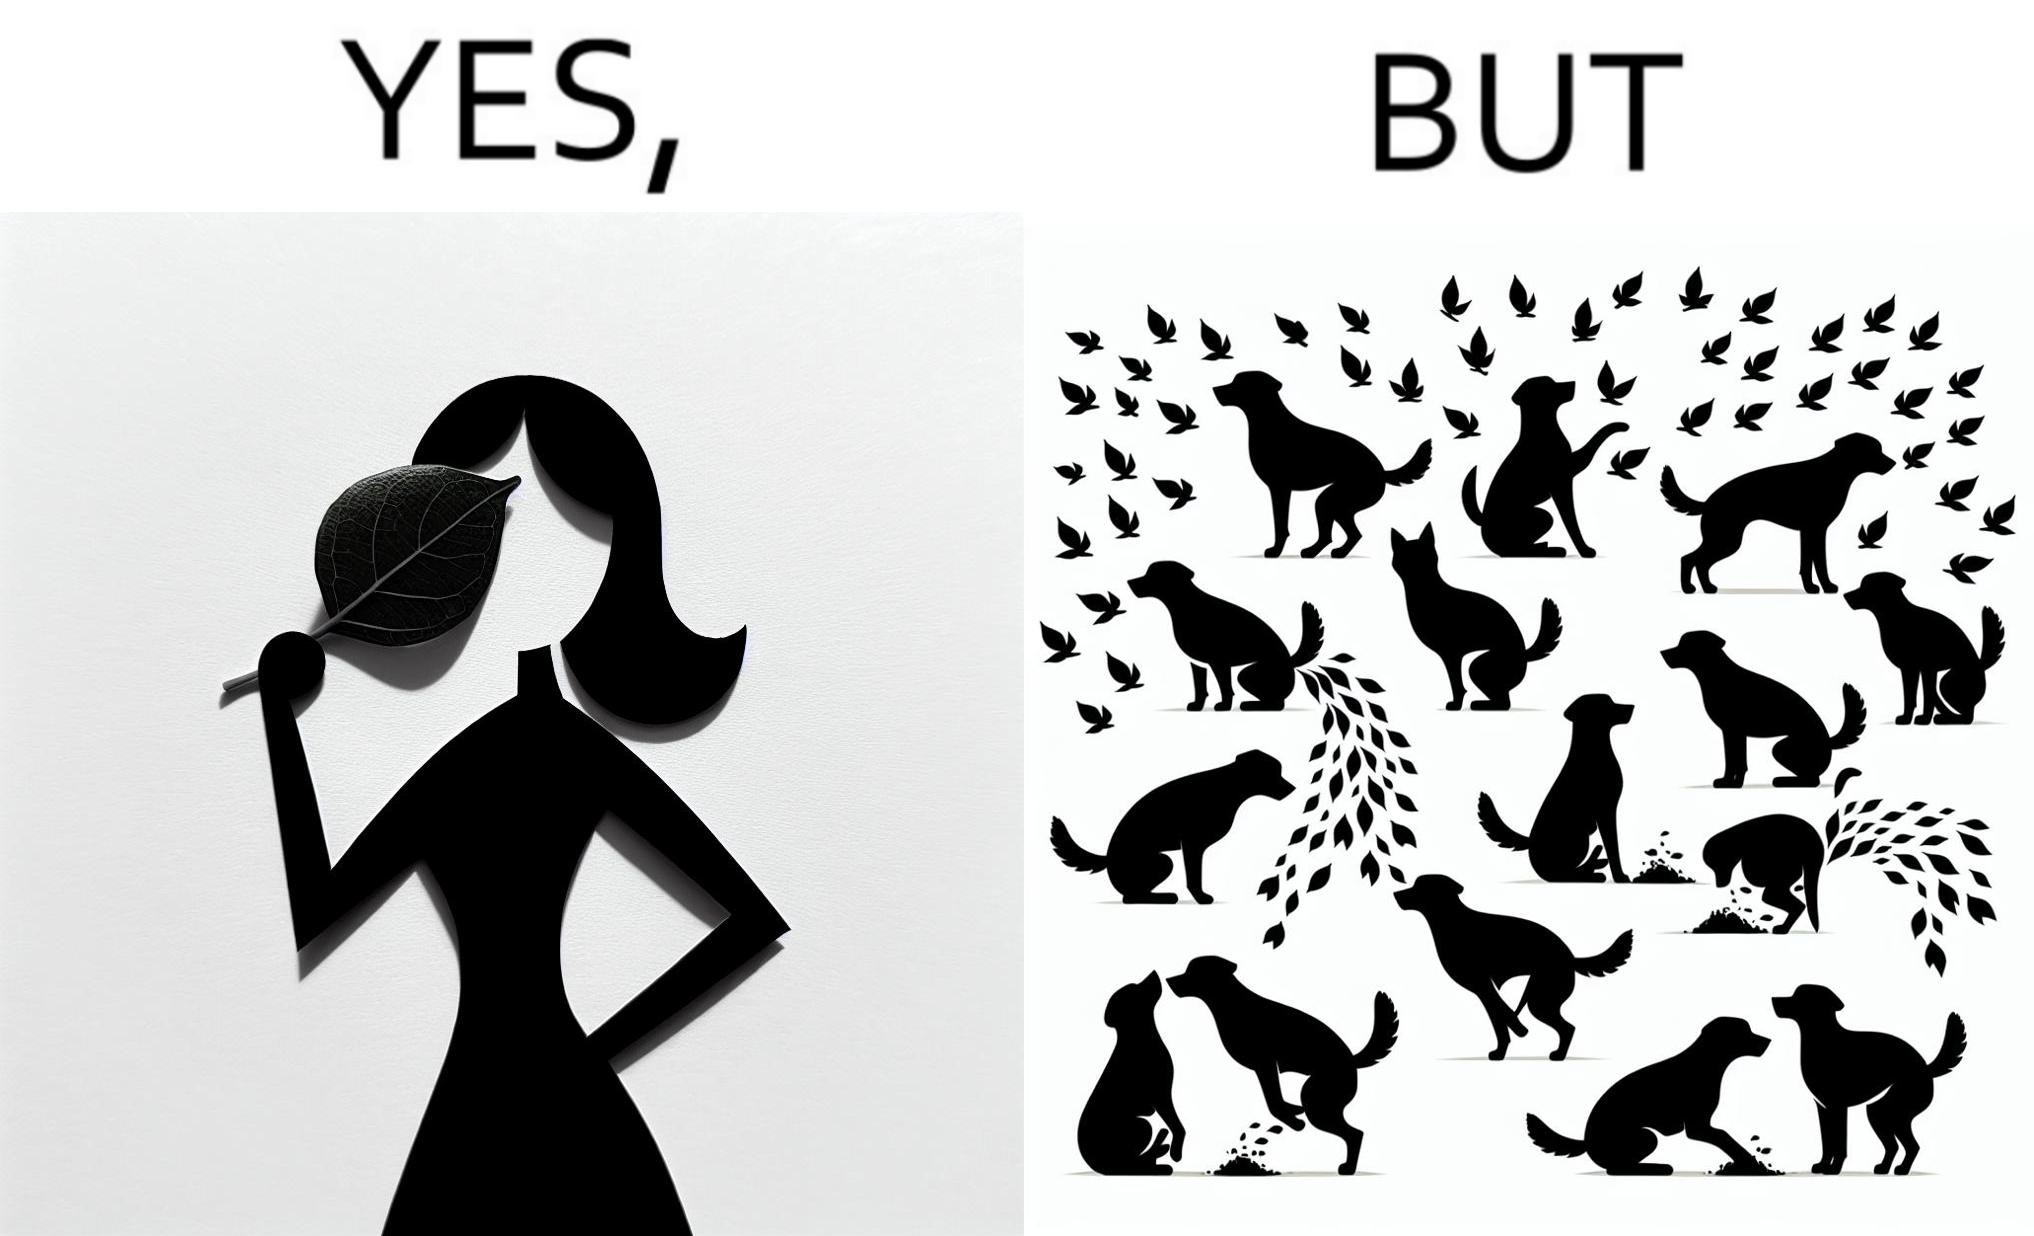Explain the humor or irony in this image. The images are funny since it show a woman holding a leaf over half of her face for a good photo but unknown to her is thale fact the same leaf might have been defecated or urinated upon by dogs and other wild animals 